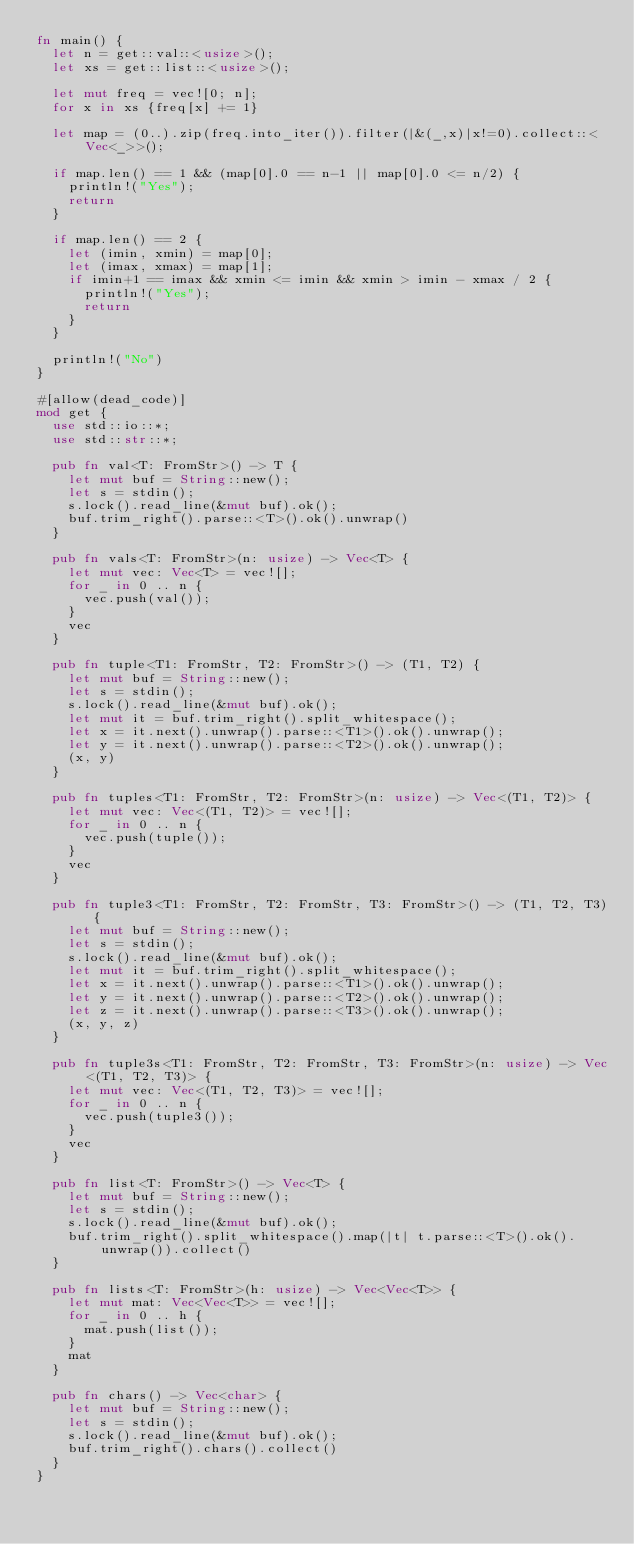Convert code to text. <code><loc_0><loc_0><loc_500><loc_500><_Rust_>fn main() {
  let n = get::val::<usize>();
  let xs = get::list::<usize>();
  
  let mut freq = vec![0; n];
  for x in xs {freq[x] += 1}
  
  let map = (0..).zip(freq.into_iter()).filter(|&(_,x)|x!=0).collect::<Vec<_>>();
  
  if map.len() == 1 && (map[0].0 == n-1 || map[0].0 <= n/2) {
    println!("Yes");
    return
  }
  
  if map.len() == 2 {
    let (imin, xmin) = map[0];
    let (imax, xmax) = map[1];
    if imin+1 == imax && xmin <= imin && xmin > imin - xmax / 2 {
      println!("Yes");
      return
    }
  }

  println!("No")
} 

#[allow(dead_code)]
mod get {
  use std::io::*;
  use std::str::*;

  pub fn val<T: FromStr>() -> T {
    let mut buf = String::new();
    let s = stdin();
    s.lock().read_line(&mut buf).ok();
    buf.trim_right().parse::<T>().ok().unwrap()
  }

  pub fn vals<T: FromStr>(n: usize) -> Vec<T> {
    let mut vec: Vec<T> = vec![];
    for _ in 0 .. n {
      vec.push(val());
    }
    vec
  }

  pub fn tuple<T1: FromStr, T2: FromStr>() -> (T1, T2) {
    let mut buf = String::new();
    let s = stdin();
    s.lock().read_line(&mut buf).ok();
    let mut it = buf.trim_right().split_whitespace();
    let x = it.next().unwrap().parse::<T1>().ok().unwrap();
    let y = it.next().unwrap().parse::<T2>().ok().unwrap();
    (x, y)
  }

  pub fn tuples<T1: FromStr, T2: FromStr>(n: usize) -> Vec<(T1, T2)> {
    let mut vec: Vec<(T1, T2)> = vec![];
    for _ in 0 .. n {
      vec.push(tuple());
    }
    vec
  }

  pub fn tuple3<T1: FromStr, T2: FromStr, T3: FromStr>() -> (T1, T2, T3) {
    let mut buf = String::new();
    let s = stdin();
    s.lock().read_line(&mut buf).ok();
    let mut it = buf.trim_right().split_whitespace();
    let x = it.next().unwrap().parse::<T1>().ok().unwrap();
    let y = it.next().unwrap().parse::<T2>().ok().unwrap();
    let z = it.next().unwrap().parse::<T3>().ok().unwrap();
    (x, y, z)
  }

  pub fn tuple3s<T1: FromStr, T2: FromStr, T3: FromStr>(n: usize) -> Vec<(T1, T2, T3)> {
    let mut vec: Vec<(T1, T2, T3)> = vec![];
    for _ in 0 .. n {
      vec.push(tuple3());
    }
    vec
  }

  pub fn list<T: FromStr>() -> Vec<T> {
    let mut buf = String::new();
    let s = stdin();
    s.lock().read_line(&mut buf).ok();
    buf.trim_right().split_whitespace().map(|t| t.parse::<T>().ok().unwrap()).collect()
  }

  pub fn lists<T: FromStr>(h: usize) -> Vec<Vec<T>> {
    let mut mat: Vec<Vec<T>> = vec![];
    for _ in 0 .. h {
      mat.push(list());
    }
    mat
  }

  pub fn chars() -> Vec<char> {
    let mut buf = String::new();
    let s = stdin();
    s.lock().read_line(&mut buf).ok();
    buf.trim_right().chars().collect()
  }
}
</code> 